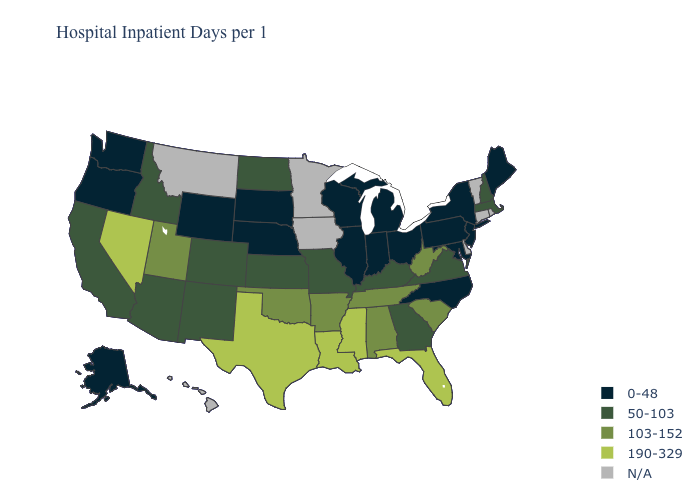What is the highest value in the USA?
Give a very brief answer. 190-329. Name the states that have a value in the range 0-48?
Write a very short answer. Alaska, Illinois, Indiana, Maine, Maryland, Michigan, Nebraska, New Jersey, New York, North Carolina, Ohio, Oregon, Pennsylvania, South Dakota, Washington, Wisconsin, Wyoming. Which states have the highest value in the USA?
Keep it brief. Florida, Louisiana, Mississippi, Nevada, Texas. What is the lowest value in the South?
Concise answer only. 0-48. What is the lowest value in the West?
Short answer required. 0-48. What is the value of Tennessee?
Keep it brief. 103-152. What is the value of Nevada?
Short answer required. 190-329. Among the states that border Wyoming , which have the lowest value?
Give a very brief answer. Nebraska, South Dakota. Is the legend a continuous bar?
Quick response, please. No. What is the value of Wyoming?
Be succinct. 0-48. Name the states that have a value in the range 50-103?
Be succinct. Arizona, California, Colorado, Georgia, Idaho, Kansas, Kentucky, Massachusetts, Missouri, New Hampshire, New Mexico, North Dakota, Virginia. Which states have the highest value in the USA?
Give a very brief answer. Florida, Louisiana, Mississippi, Nevada, Texas. Name the states that have a value in the range 0-48?
Answer briefly. Alaska, Illinois, Indiana, Maine, Maryland, Michigan, Nebraska, New Jersey, New York, North Carolina, Ohio, Oregon, Pennsylvania, South Dakota, Washington, Wisconsin, Wyoming. What is the value of Washington?
Short answer required. 0-48. What is the value of Iowa?
Quick response, please. N/A. 